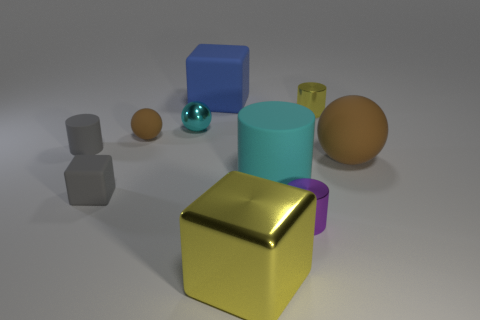Subtract all blocks. How many objects are left? 7 Subtract all red spheres. Subtract all big cyan rubber things. How many objects are left? 9 Add 2 big blue things. How many big blue things are left? 3 Add 1 large rubber things. How many large rubber things exist? 4 Subtract 0 brown cylinders. How many objects are left? 10 